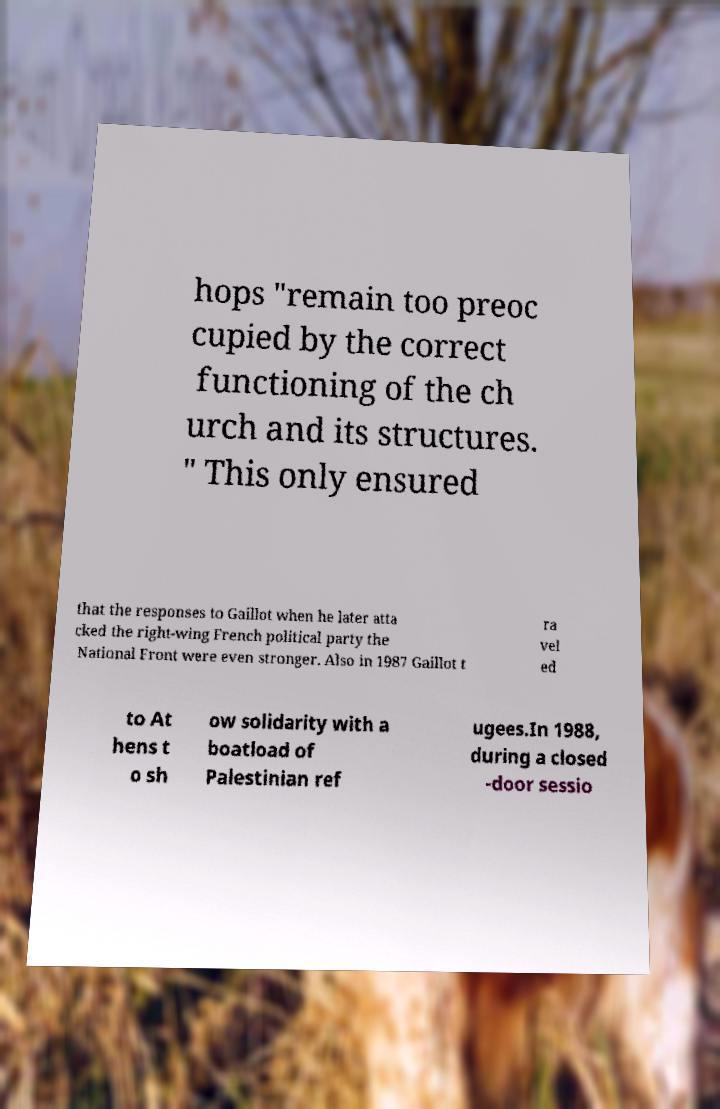What messages or text are displayed in this image? I need them in a readable, typed format. hops "remain too preoc cupied by the correct functioning of the ch urch and its structures. " This only ensured that the responses to Gaillot when he later atta cked the right-wing French political party the National Front were even stronger. Also in 1987 Gaillot t ra vel ed to At hens t o sh ow solidarity with a boatload of Palestinian ref ugees.In 1988, during a closed -door sessio 